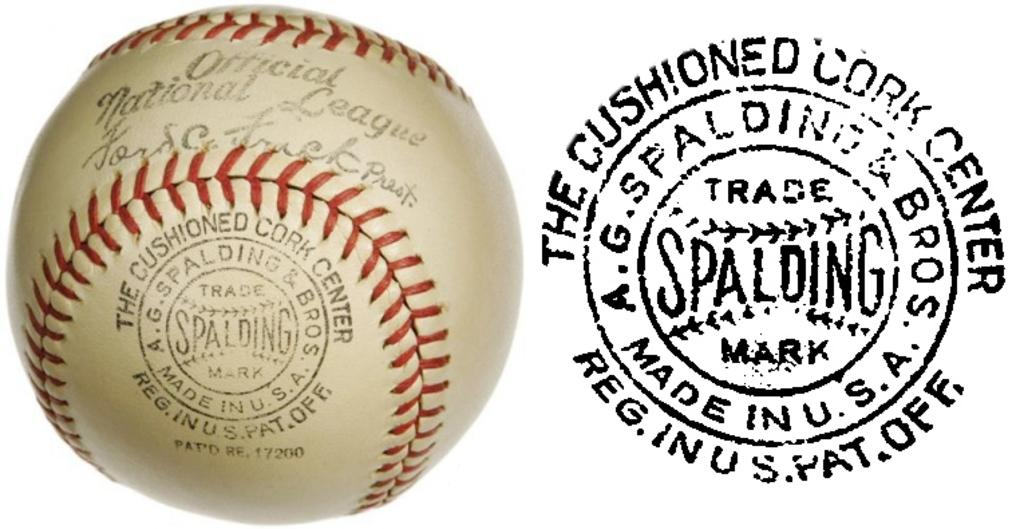<image>
Summarize the visual content of the image. The baseball is made by the company Spalding 